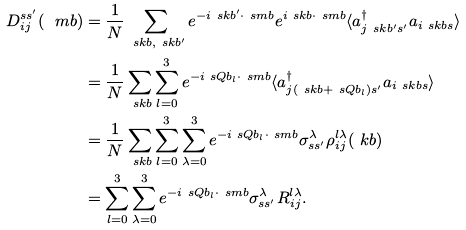Convert formula to latex. <formula><loc_0><loc_0><loc_500><loc_500>D ^ { s s ^ { \prime } } _ { i j } ( \ m b ) & = \frac { 1 } { N } \sum _ { \ s k b , \ s k b ^ { \prime } } e ^ { - i \ s k b ^ { \prime } \cdot \ s m b } e ^ { i \ s k b \cdot \ s m b } \langle a ^ { \dag } _ { j \ s k b ^ { \prime } s ^ { \prime } } a _ { i \ s k b s } \rangle \\ & = \frac { 1 } { N } \sum _ { \ s k b } \sum _ { l = 0 } ^ { 3 } e ^ { - i \ s Q b _ { l } \cdot \ s m b } \langle a ^ { \dag } _ { j ( \ s k b + \ s Q b _ { l } ) s ^ { \prime } } a _ { i \ s k b s } \rangle \\ & = \frac { 1 } { N } \sum _ { \ s k b } \sum _ { l = 0 } ^ { 3 } \sum _ { \lambda = 0 } ^ { 3 } e ^ { - i \ s Q b _ { l } \cdot \ s m b } \sigma ^ { \lambda } _ { s s ^ { \prime } } \rho ^ { l \lambda } _ { i j } ( \ k b ) \\ & = \sum _ { l = 0 } ^ { 3 } \sum _ { \lambda = 0 } ^ { 3 } e ^ { - i \ s Q b _ { l } \cdot \ s m b } \sigma ^ { \lambda } _ { s s ^ { \prime } } R ^ { l \lambda } _ { i j } .</formula> 